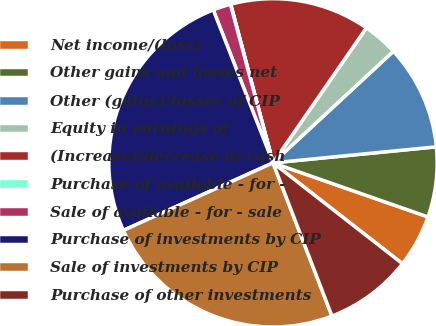<chart> <loc_0><loc_0><loc_500><loc_500><pie_chart><fcel>Net income/(loss)<fcel>Other gains and losses net<fcel>Other (gains)/losses of CIP<fcel>Equity in earnings of<fcel>(Increase)/decrease in cash<fcel>Purchase of available - for -<fcel>Sale of available - for - sale<fcel>Purchase of investments by CIP<fcel>Sale of investments by CIP<fcel>Purchase of other investments<nl><fcel>5.19%<fcel>6.9%<fcel>10.34%<fcel>3.47%<fcel>13.78%<fcel>0.03%<fcel>1.75%<fcel>25.82%<fcel>24.1%<fcel>8.62%<nl></chart> 